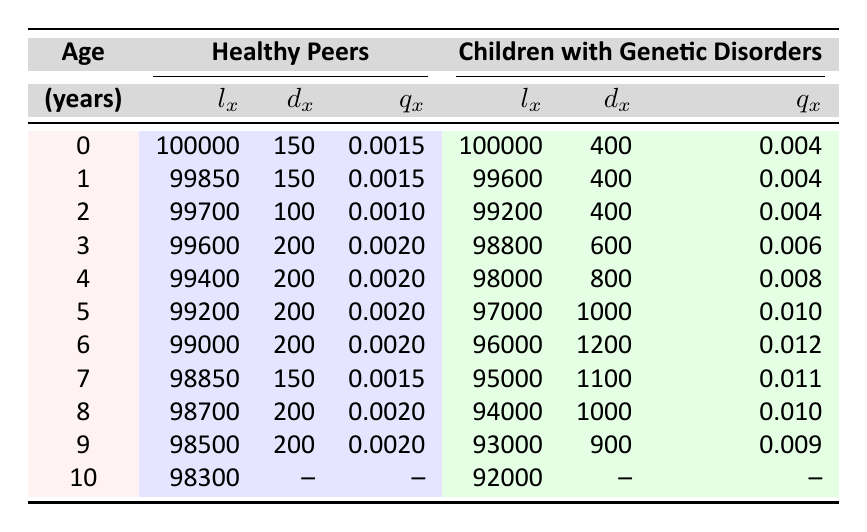What is the death rate (qx) for healthy peers at age 3? From the table, we can find the row for age 3 in the healthy peers section. The value for qx at that age is listed as 0.0020.
Answer: 0.0020 How many children with genetic disorders are alive at age 6? Referring to the children with genetic disorders section at age 6, the lx value (number alive) is 96000.
Answer: 96000 What is the total number of deaths (dx) for healthy peers from ages 0 to 10? To find the total deaths for healthy peers, sum the dx values for each age from 0 to 10: 150 + 150 + 100 + 200 + 200 + 200 + 200 + 150 + 200 + 200 = 1950.
Answer: 1950 Is the death rate (qx) higher for children with genetic disorders than for their healthy peers at age 5? Comparing the values, the death rate for children with genetic disorders at age 5 is 0.010, while for healthy peers it is 0.0020. Since 0.010 is greater than 0.0020, the statement is true.
Answer: Yes What is the difference in death rate (qx) between children with genetic disorders and healthy peers at age 4? The qx for healthy peers at age 4 is 0.0020, and for children with genetic disorders, it is 0.008. The difference is calculated as 0.008 - 0.0020 = 0.006.
Answer: 0.006 What is the average number of deaths (dx) for children with genetic disorders from ages 0 to 10? To calculate the average number of deaths, we first sum the dx values for each age from 0 to 10: 400 + 400 + 400 + 600 + 800 + 1000 + 1200 + 1100 + 1000 + 900 = 5100. Since there are 10 data points, we divide this sum by 10: 5100 / 10 = 510.
Answer: 510 At what age do children with genetic disorders have the highest number of deaths? By examining the dx values for children with genetic disorders, we see that the highest value is 1200 at age 6.
Answer: Age 6 What percentage of healthy peers die by age 3? To find the percentage of healthy peers who die by age 3, calculate the total deaths from age 0 to 3, which is 150 + 150 + 100 + 200 = 600. Then divide by the starting population of 100000 and multiply by 100: (600 / 100000) * 100 = 0.6%.
Answer: 0.6% Is the number of children with genetic disorders alive at age 10 greater than those alive at age 9? From the table, at age 10, there are 92000 children with genetic disorders, and at age 9, there are 93000. Since 92000 is less than 93000, the statement is false.
Answer: No 